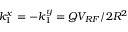Convert formula to latex. <formula><loc_0><loc_0><loc_500><loc_500>k _ { 1 } ^ { x } = - k _ { 1 } ^ { y } = Q V _ { R F } / 2 R ^ { 2 }</formula> 